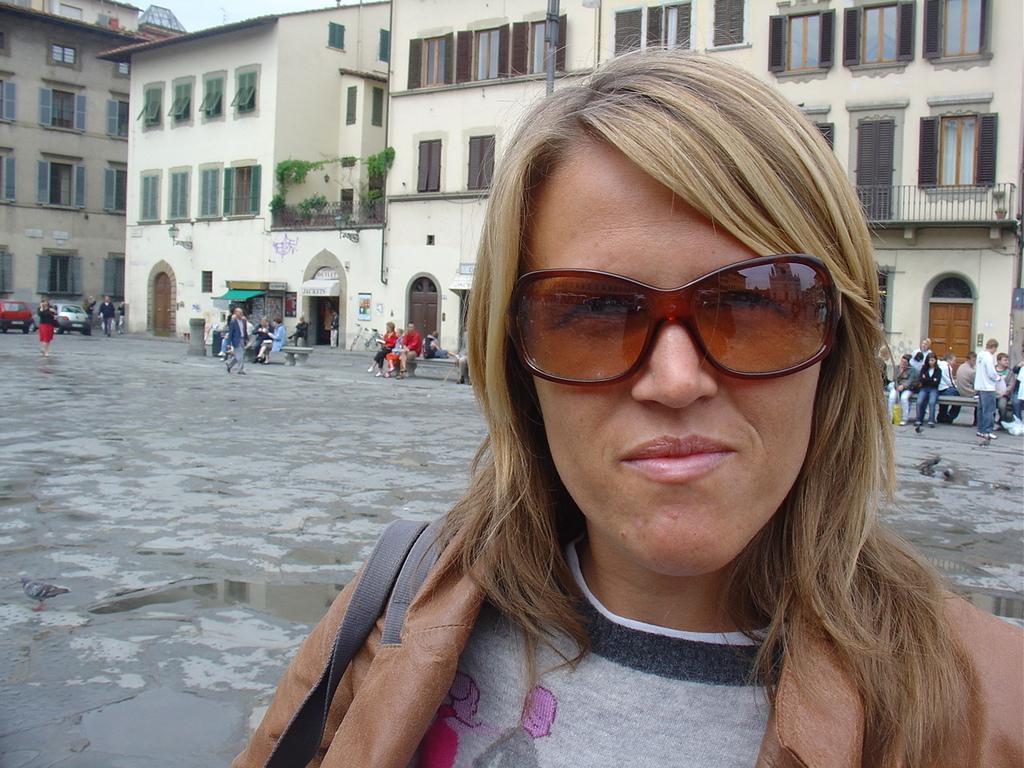Describe this image in one or two sentences. In this image we can see few people on the ground, few people are sitting on the benches and in the background there are few buildings, a creeper plants to the building and cars on the ground. 